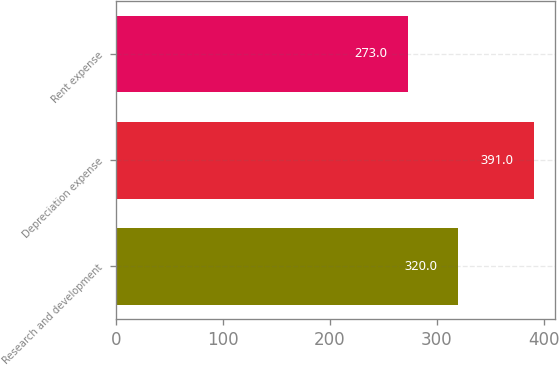Convert chart to OTSL. <chart><loc_0><loc_0><loc_500><loc_500><bar_chart><fcel>Research and development<fcel>Depreciation expense<fcel>Rent expense<nl><fcel>320<fcel>391<fcel>273<nl></chart> 